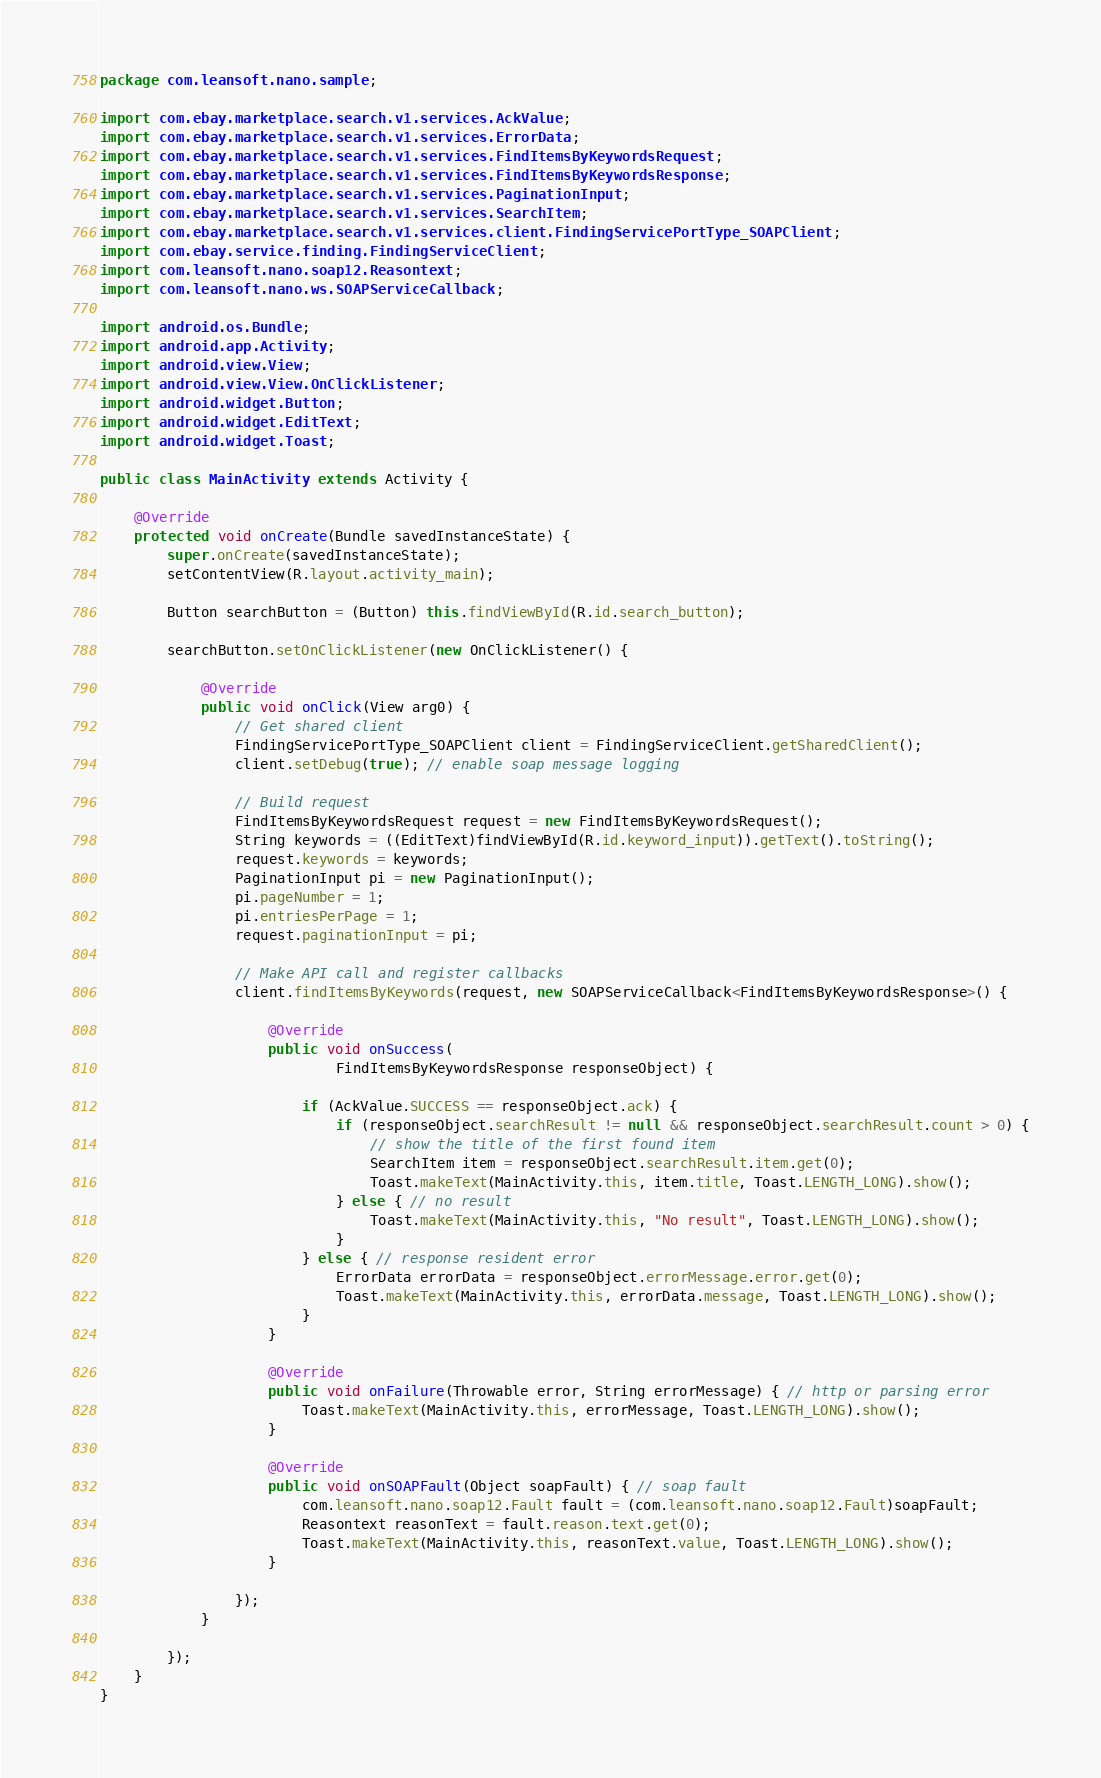<code> <loc_0><loc_0><loc_500><loc_500><_Java_>package com.leansoft.nano.sample;

import com.ebay.marketplace.search.v1.services.AckValue;
import com.ebay.marketplace.search.v1.services.ErrorData;
import com.ebay.marketplace.search.v1.services.FindItemsByKeywordsRequest;
import com.ebay.marketplace.search.v1.services.FindItemsByKeywordsResponse;
import com.ebay.marketplace.search.v1.services.PaginationInput;
import com.ebay.marketplace.search.v1.services.SearchItem;
import com.ebay.marketplace.search.v1.services.client.FindingServicePortType_SOAPClient;
import com.ebay.service.finding.FindingServiceClient;
import com.leansoft.nano.soap12.Reasontext;
import com.leansoft.nano.ws.SOAPServiceCallback;

import android.os.Bundle;
import android.app.Activity;
import android.view.View;
import android.view.View.OnClickListener;
import android.widget.Button;
import android.widget.EditText;
import android.widget.Toast;

public class MainActivity extends Activity {

	@Override
	protected void onCreate(Bundle savedInstanceState) {
		super.onCreate(savedInstanceState);
		setContentView(R.layout.activity_main);
		
		Button searchButton = (Button) this.findViewById(R.id.search_button);
		
		searchButton.setOnClickListener(new OnClickListener() {

			@Override
			public void onClick(View arg0) {
				// Get shared client
				FindingServicePortType_SOAPClient client = FindingServiceClient.getSharedClient();
				client.setDebug(true); // enable soap message logging
				
				// Build request
				FindItemsByKeywordsRequest request = new FindItemsByKeywordsRequest();
				String keywords = ((EditText)findViewById(R.id.keyword_input)).getText().toString();
				request.keywords = keywords;
				PaginationInput pi = new PaginationInput();
				pi.pageNumber = 1;
				pi.entriesPerPage = 1;
				request.paginationInput = pi;
				
				// Make API call and register callbacks
				client.findItemsByKeywords(request, new SOAPServiceCallback<FindItemsByKeywordsResponse>() {

					@Override
					public void onSuccess(
							FindItemsByKeywordsResponse responseObject) {
						
						if (AckValue.SUCCESS == responseObject.ack) {
							if (responseObject.searchResult != null && responseObject.searchResult.count > 0) {
								// show the title of the first found item
								SearchItem item = responseObject.searchResult.item.get(0);
								Toast.makeText(MainActivity.this, item.title, Toast.LENGTH_LONG).show();
							} else { // no result
								Toast.makeText(MainActivity.this, "No result", Toast.LENGTH_LONG).show();
							}
						} else { // response resident error
							ErrorData errorData = responseObject.errorMessage.error.get(0);
							Toast.makeText(MainActivity.this, errorData.message, Toast.LENGTH_LONG).show();
						}
					}

					@Override
					public void onFailure(Throwable error, String errorMessage) { // http or parsing error
						Toast.makeText(MainActivity.this, errorMessage, Toast.LENGTH_LONG).show();
					}

					@Override
					public void onSOAPFault(Object soapFault) { // soap fault
						com.leansoft.nano.soap12.Fault fault = (com.leansoft.nano.soap12.Fault)soapFault;
						Reasontext reasonText = fault.reason.text.get(0);
						Toast.makeText(MainActivity.this, reasonText.value, Toast.LENGTH_LONG).show();
					}
					
				});
			}
			
		});
	}
}
</code> 